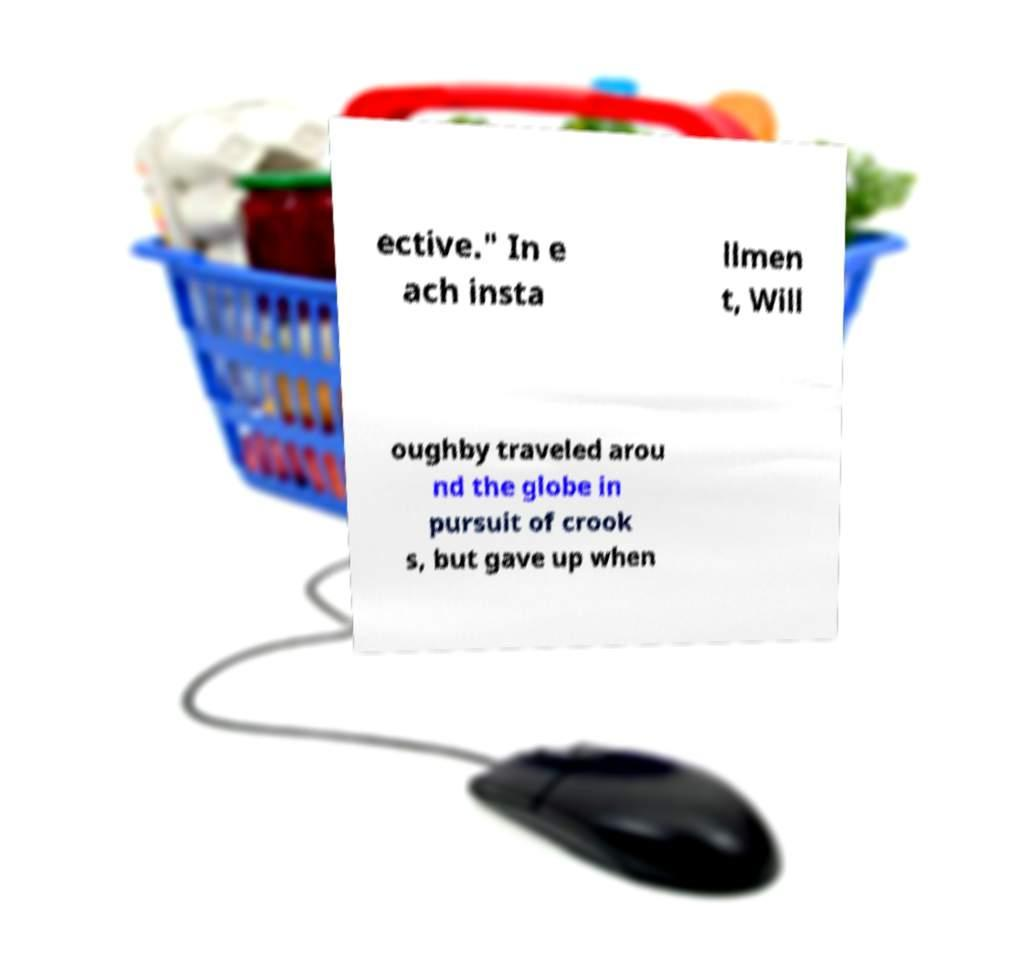Can you read and provide the text displayed in the image?This photo seems to have some interesting text. Can you extract and type it out for me? ective." In e ach insta llmen t, Will oughby traveled arou nd the globe in pursuit of crook s, but gave up when 